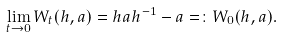<formula> <loc_0><loc_0><loc_500><loc_500>\lim _ { t \to 0 } W _ { t } ( h , a ) = h a h ^ { - 1 } - a = \colon W _ { 0 } ( h , a ) .</formula> 